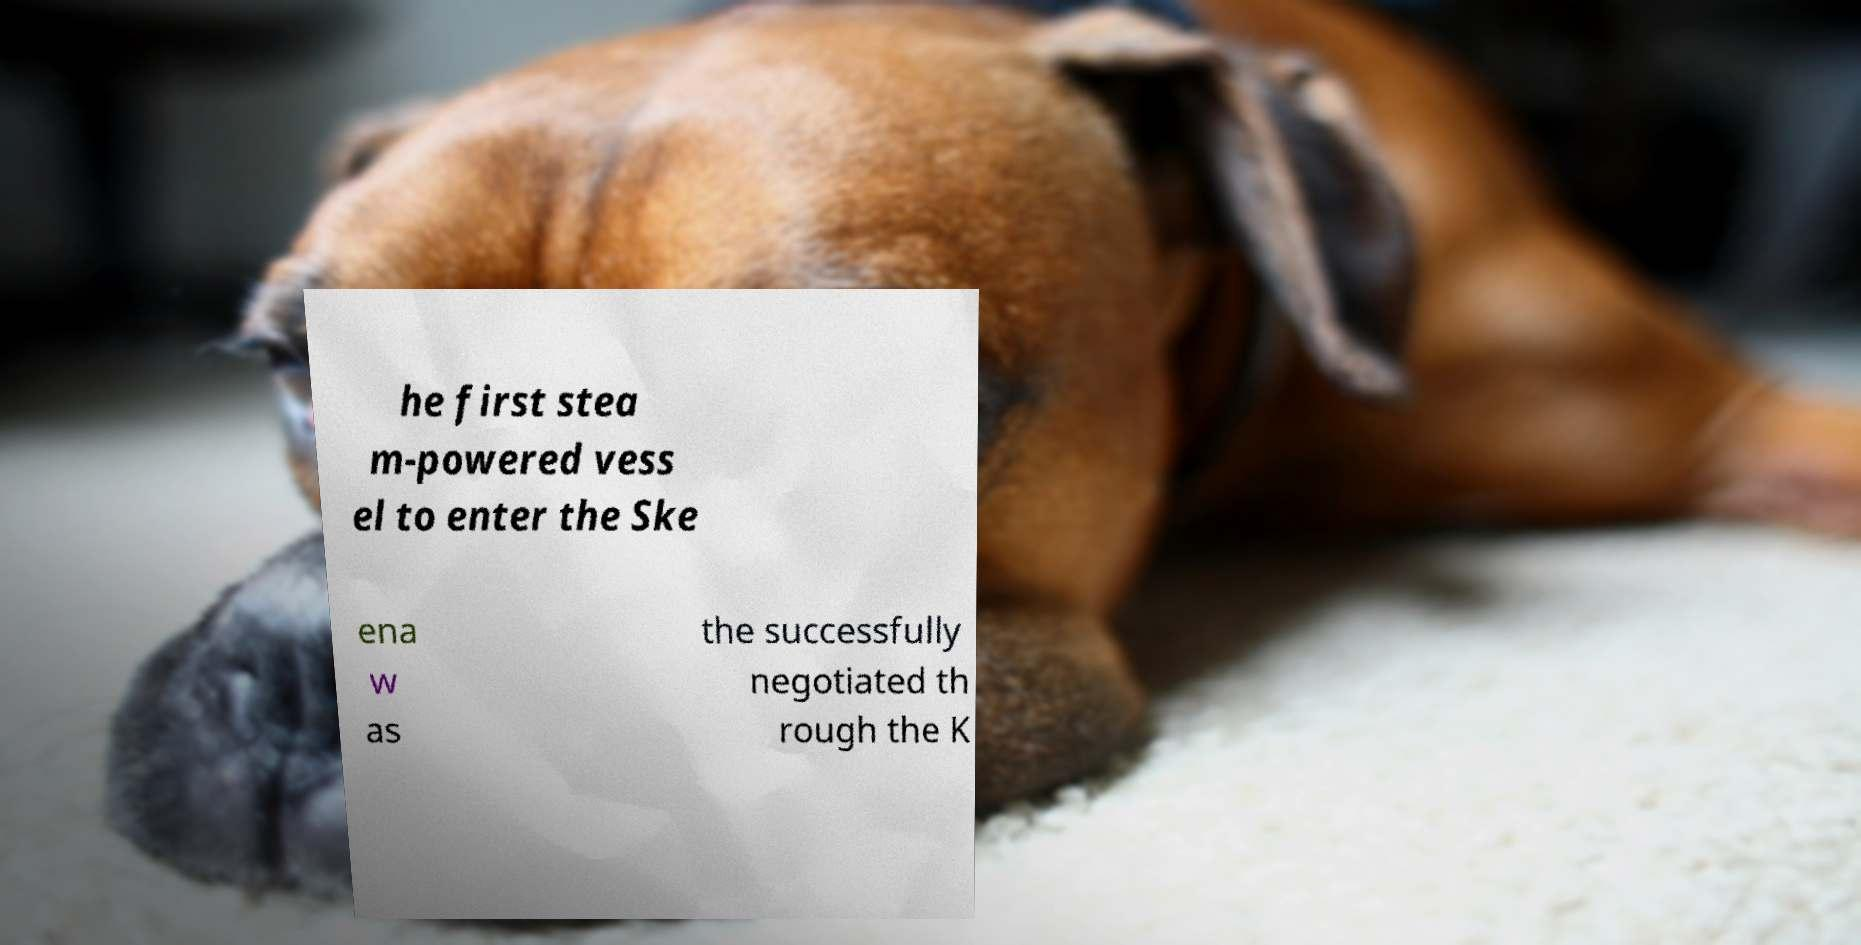Could you extract and type out the text from this image? he first stea m-powered vess el to enter the Ske ena w as the successfully negotiated th rough the K 